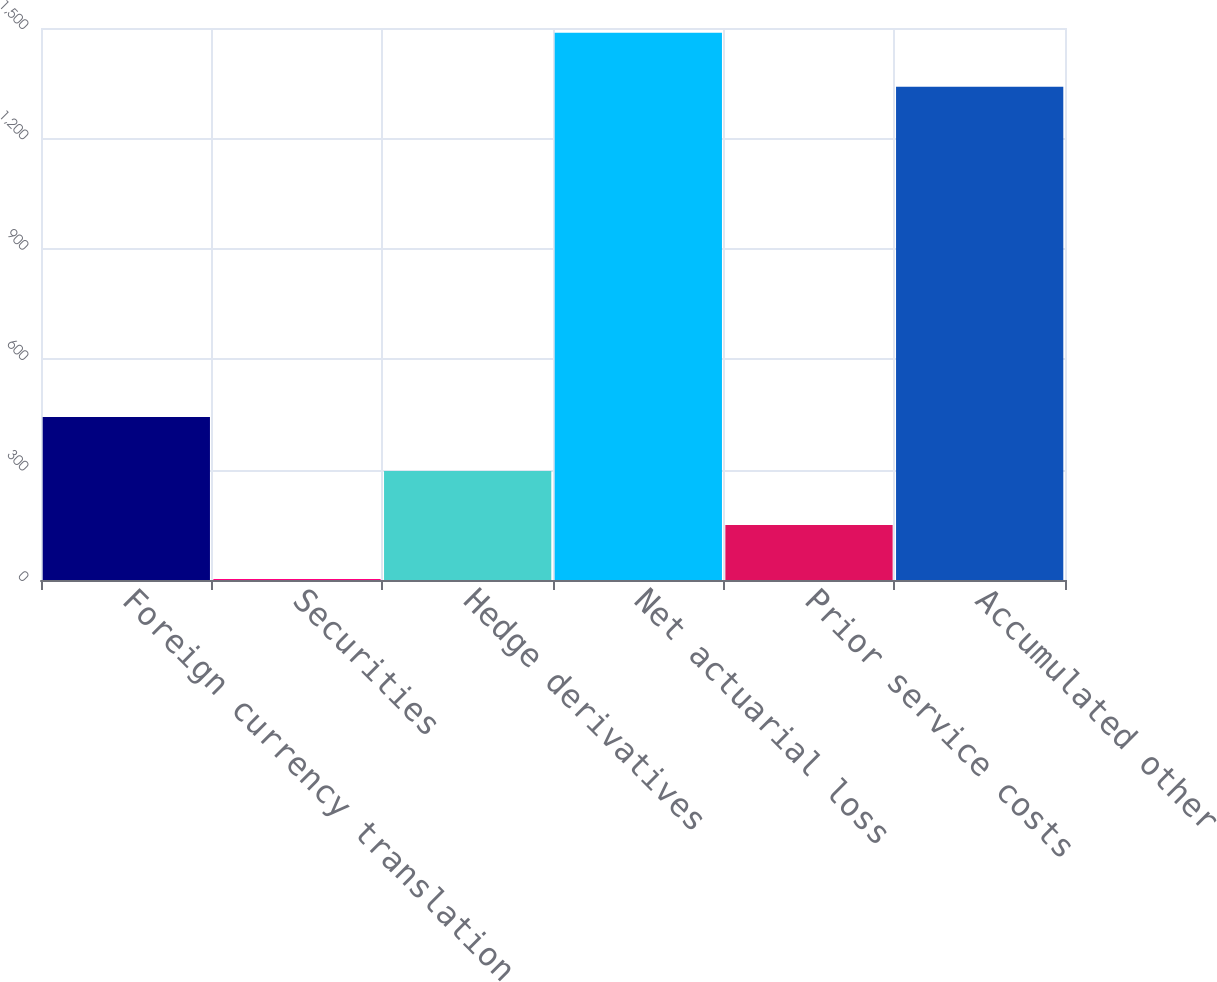Convert chart to OTSL. <chart><loc_0><loc_0><loc_500><loc_500><bar_chart><fcel>Foreign currency translation<fcel>Securities<fcel>Hedge derivatives<fcel>Net actuarial loss<fcel>Prior service costs<fcel>Accumulated other<nl><fcel>442.79<fcel>2.9<fcel>296.16<fcel>1486.93<fcel>149.53<fcel>1340.3<nl></chart> 